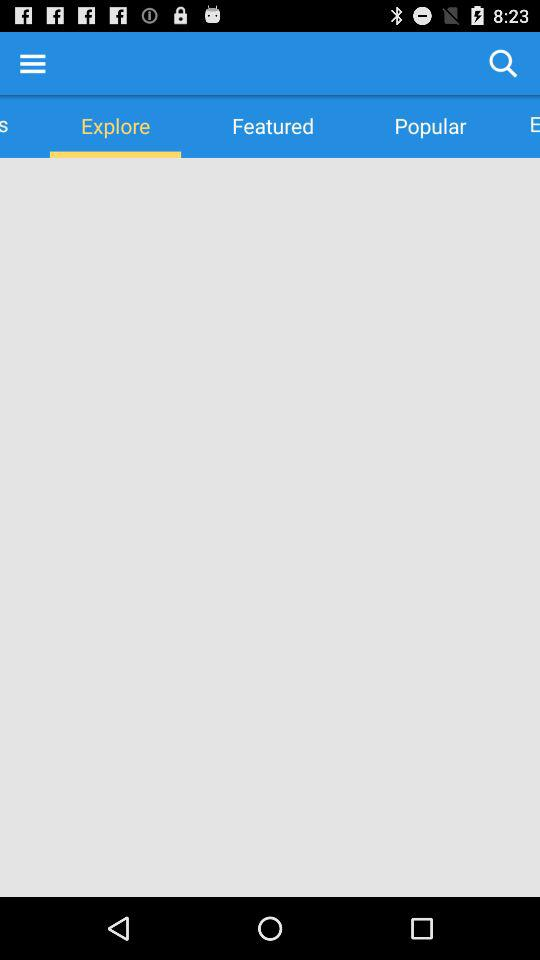Which tab am I using? You are using "Explore" tab. 